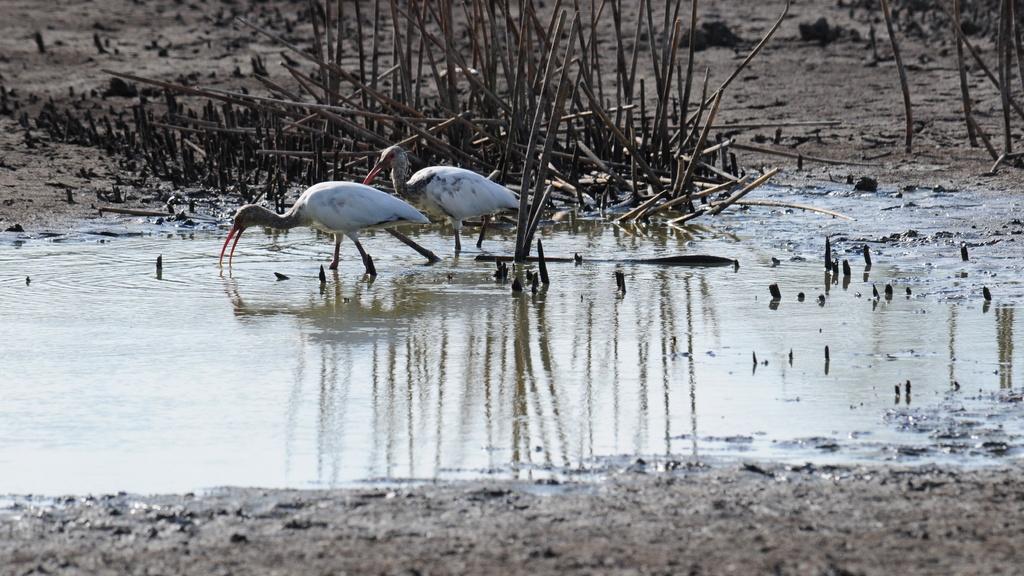Could you give a brief overview of what you see in this image? In the center of the image we can see cranes. At the bottom there is water. In the background there are sticks. 